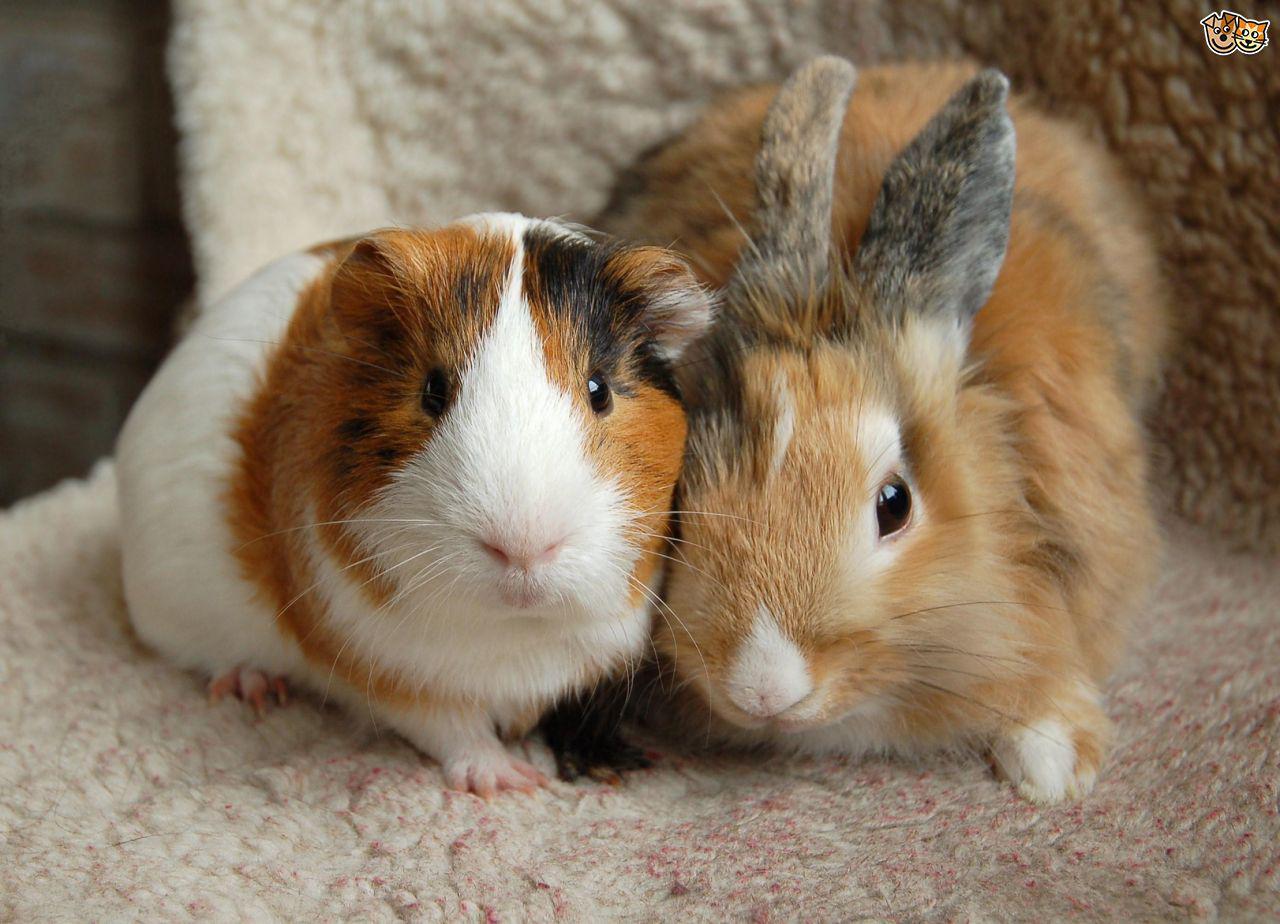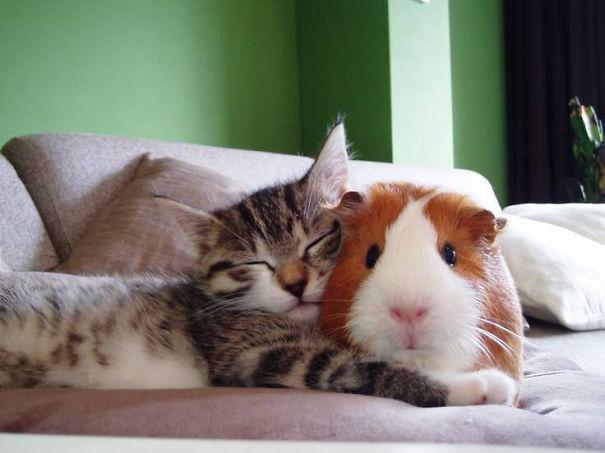The first image is the image on the left, the second image is the image on the right. For the images displayed, is the sentence "There are three species of animals." factually correct? Answer yes or no. Yes. The first image is the image on the left, the second image is the image on the right. Assess this claim about the two images: "Each image shows a guinea pig posed next to a different kind of pet, and one image shows a cat sleeping with its head against an awake guinea pig.". Correct or not? Answer yes or no. Yes. 